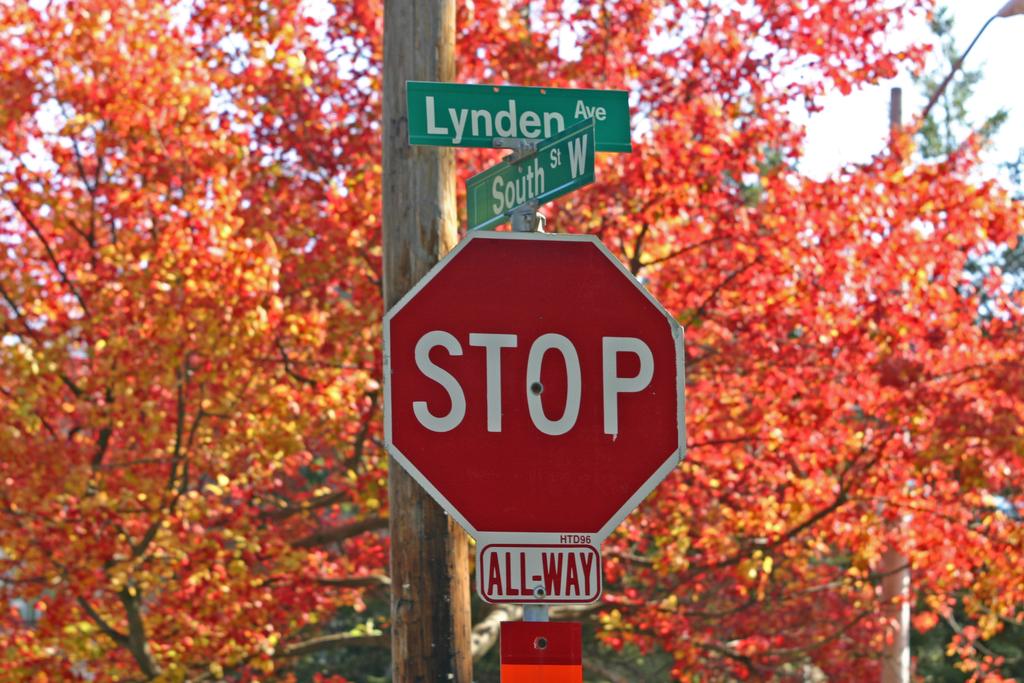What are the names of the two streets at the intersection?
Provide a succinct answer. Lynden and south. What type of "stop" intersection does the sign indicate?
Your answer should be compact. All-way. 